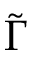Convert formula to latex. <formula><loc_0><loc_0><loc_500><loc_500>\widetilde { \Gamma }</formula> 